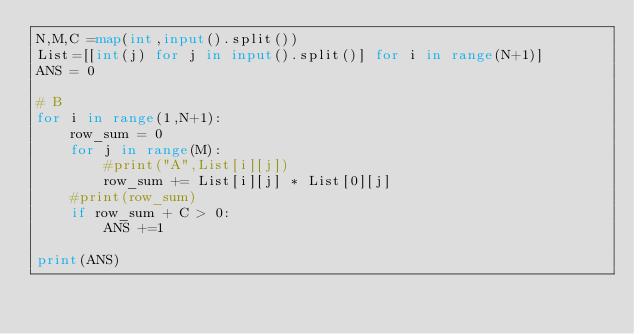Convert code to text. <code><loc_0><loc_0><loc_500><loc_500><_Python_>N,M,C =map(int,input().split())
List=[[int(j) for j in input().split()] for i in range(N+1)]
ANS = 0

# B
for i in range(1,N+1):
    row_sum = 0
    for j in range(M):
        #print("A",List[i][j])
        row_sum += List[i][j] * List[0][j]
    #print(row_sum)
    if row_sum + C > 0:
        ANS +=1

print(ANS)</code> 